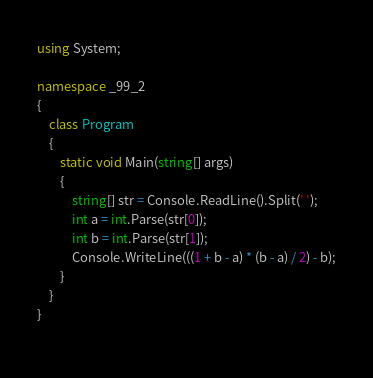Convert code to text. <code><loc_0><loc_0><loc_500><loc_500><_C#_>using System;

namespace _99_2
{
    class Program
    {
        static void Main(string[] args)
        {
			string[] str = Console.ReadLine().Split(' ');
			int a = int.Parse(str[0]);
			int b = int.Parse(str[1]);
			Console.WriteLine(((1 + b - a) * (b - a) / 2) - b);
		}
    }
}
 </code> 